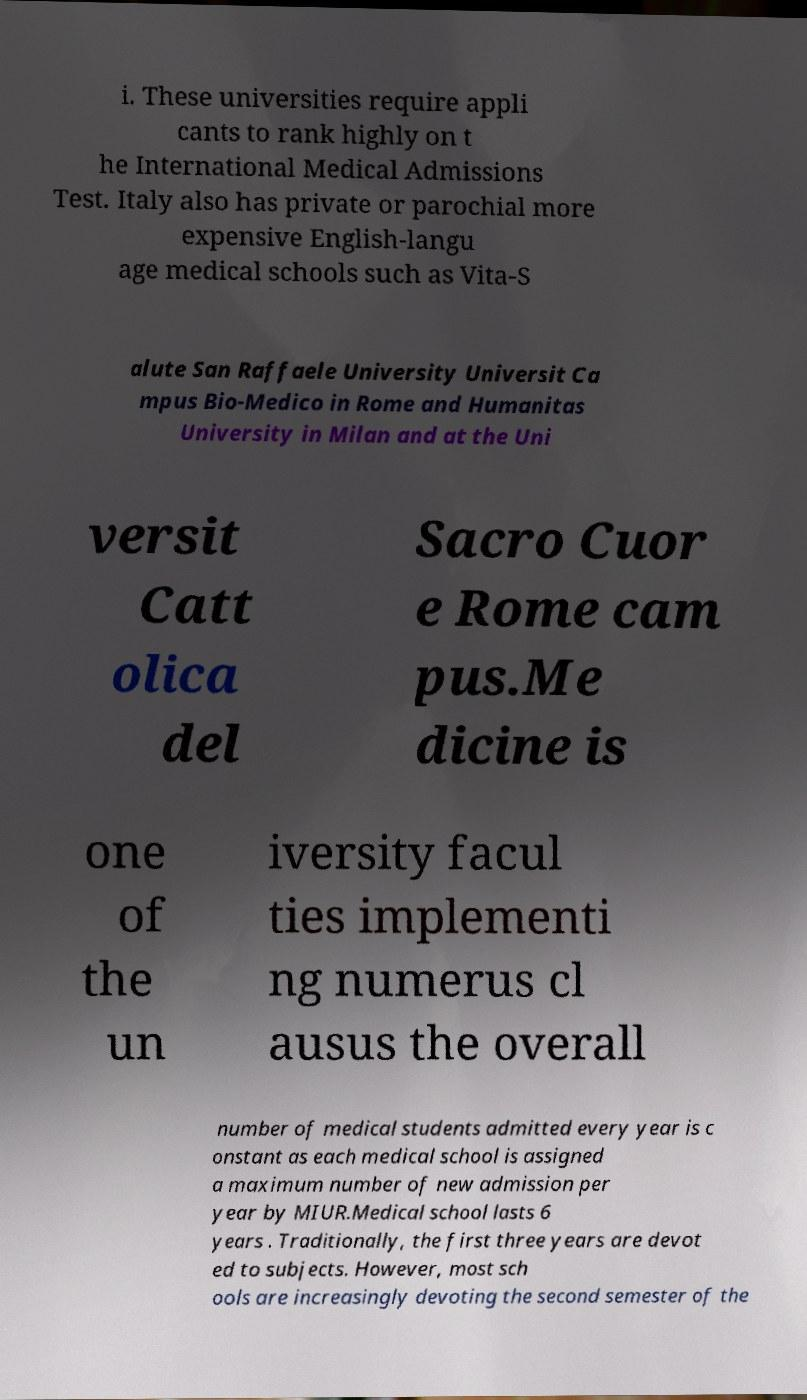I need the written content from this picture converted into text. Can you do that? i. These universities require appli cants to rank highly on t he International Medical Admissions Test. Italy also has private or parochial more expensive English-langu age medical schools such as Vita-S alute San Raffaele University Universit Ca mpus Bio-Medico in Rome and Humanitas University in Milan and at the Uni versit Catt olica del Sacro Cuor e Rome cam pus.Me dicine is one of the un iversity facul ties implementi ng numerus cl ausus the overall number of medical students admitted every year is c onstant as each medical school is assigned a maximum number of new admission per year by MIUR.Medical school lasts 6 years . Traditionally, the first three years are devot ed to subjects. However, most sch ools are increasingly devoting the second semester of the 